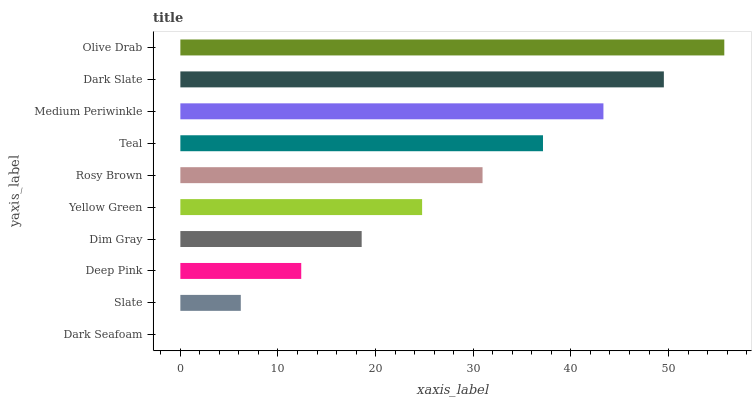Is Dark Seafoam the minimum?
Answer yes or no. Yes. Is Olive Drab the maximum?
Answer yes or no. Yes. Is Slate the minimum?
Answer yes or no. No. Is Slate the maximum?
Answer yes or no. No. Is Slate greater than Dark Seafoam?
Answer yes or no. Yes. Is Dark Seafoam less than Slate?
Answer yes or no. Yes. Is Dark Seafoam greater than Slate?
Answer yes or no. No. Is Slate less than Dark Seafoam?
Answer yes or no. No. Is Rosy Brown the high median?
Answer yes or no. Yes. Is Yellow Green the low median?
Answer yes or no. Yes. Is Olive Drab the high median?
Answer yes or no. No. Is Medium Periwinkle the low median?
Answer yes or no. No. 